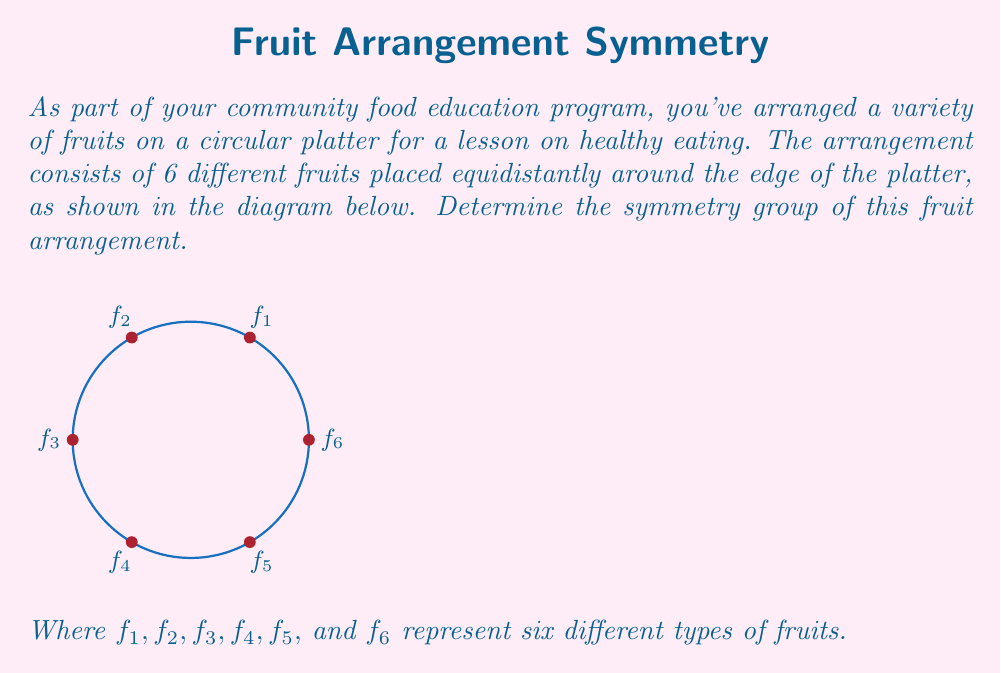Provide a solution to this math problem. To determine the symmetry group of this fruit arrangement, we need to consider all the transformations that leave the arrangement unchanged. Let's go through this step-by-step:

1) Rotational symmetries:
   - The arrangement has 6-fold rotational symmetry.
   - Rotations by multiples of 60° (or $\frac{\pi}{3}$ radians) preserve the arrangement.
   - There are 6 distinct rotations: 0°, 60°, 120°, 180°, 240°, 300°.

2) Reflection symmetries:
   - There are 6 lines of reflection, each passing through the center and a fruit.

3) Total number of symmetries:
   - 6 rotations + 6 reflections = 12 symmetries

4) Group structure:
   - This group of symmetries is known as the dihedral group of order 12, denoted as $D_6$ or $D_{12}$.
   
5) Group properties:
   - It's non-abelian (rotations and reflections don't always commute).
   - It has two generators: a rotation by 60° and a reflection.
   - Its order is 12.

6) Presentation:
   The group can be presented as:
   $$D_6 = \langle r, s | r^6 = s^2 = 1, srs = r^{-1} \rangle$$
   where $r$ represents a 60° rotation and $s$ represents a reflection.

Therefore, the symmetry group of this fruit arrangement is the dihedral group $D_6$ (or $D_{12}$).
Answer: $D_6$ (or $D_{12}$) 